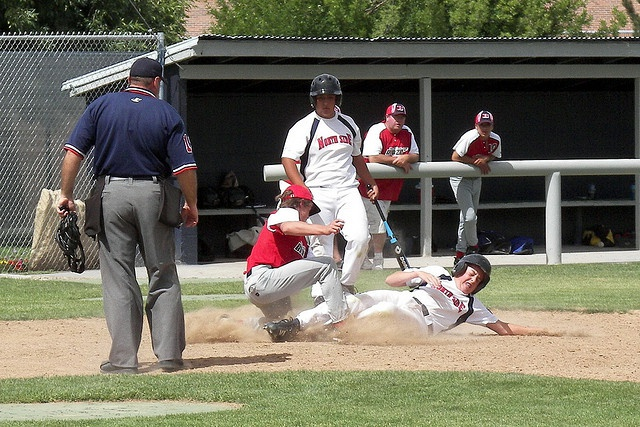Describe the objects in this image and their specific colors. I can see people in black, gray, and navy tones, people in black, white, darkgray, and gray tones, people in black, lightgray, darkgray, and gray tones, people in black, white, tan, darkgray, and gray tones, and people in black, maroon, darkgray, white, and gray tones in this image. 